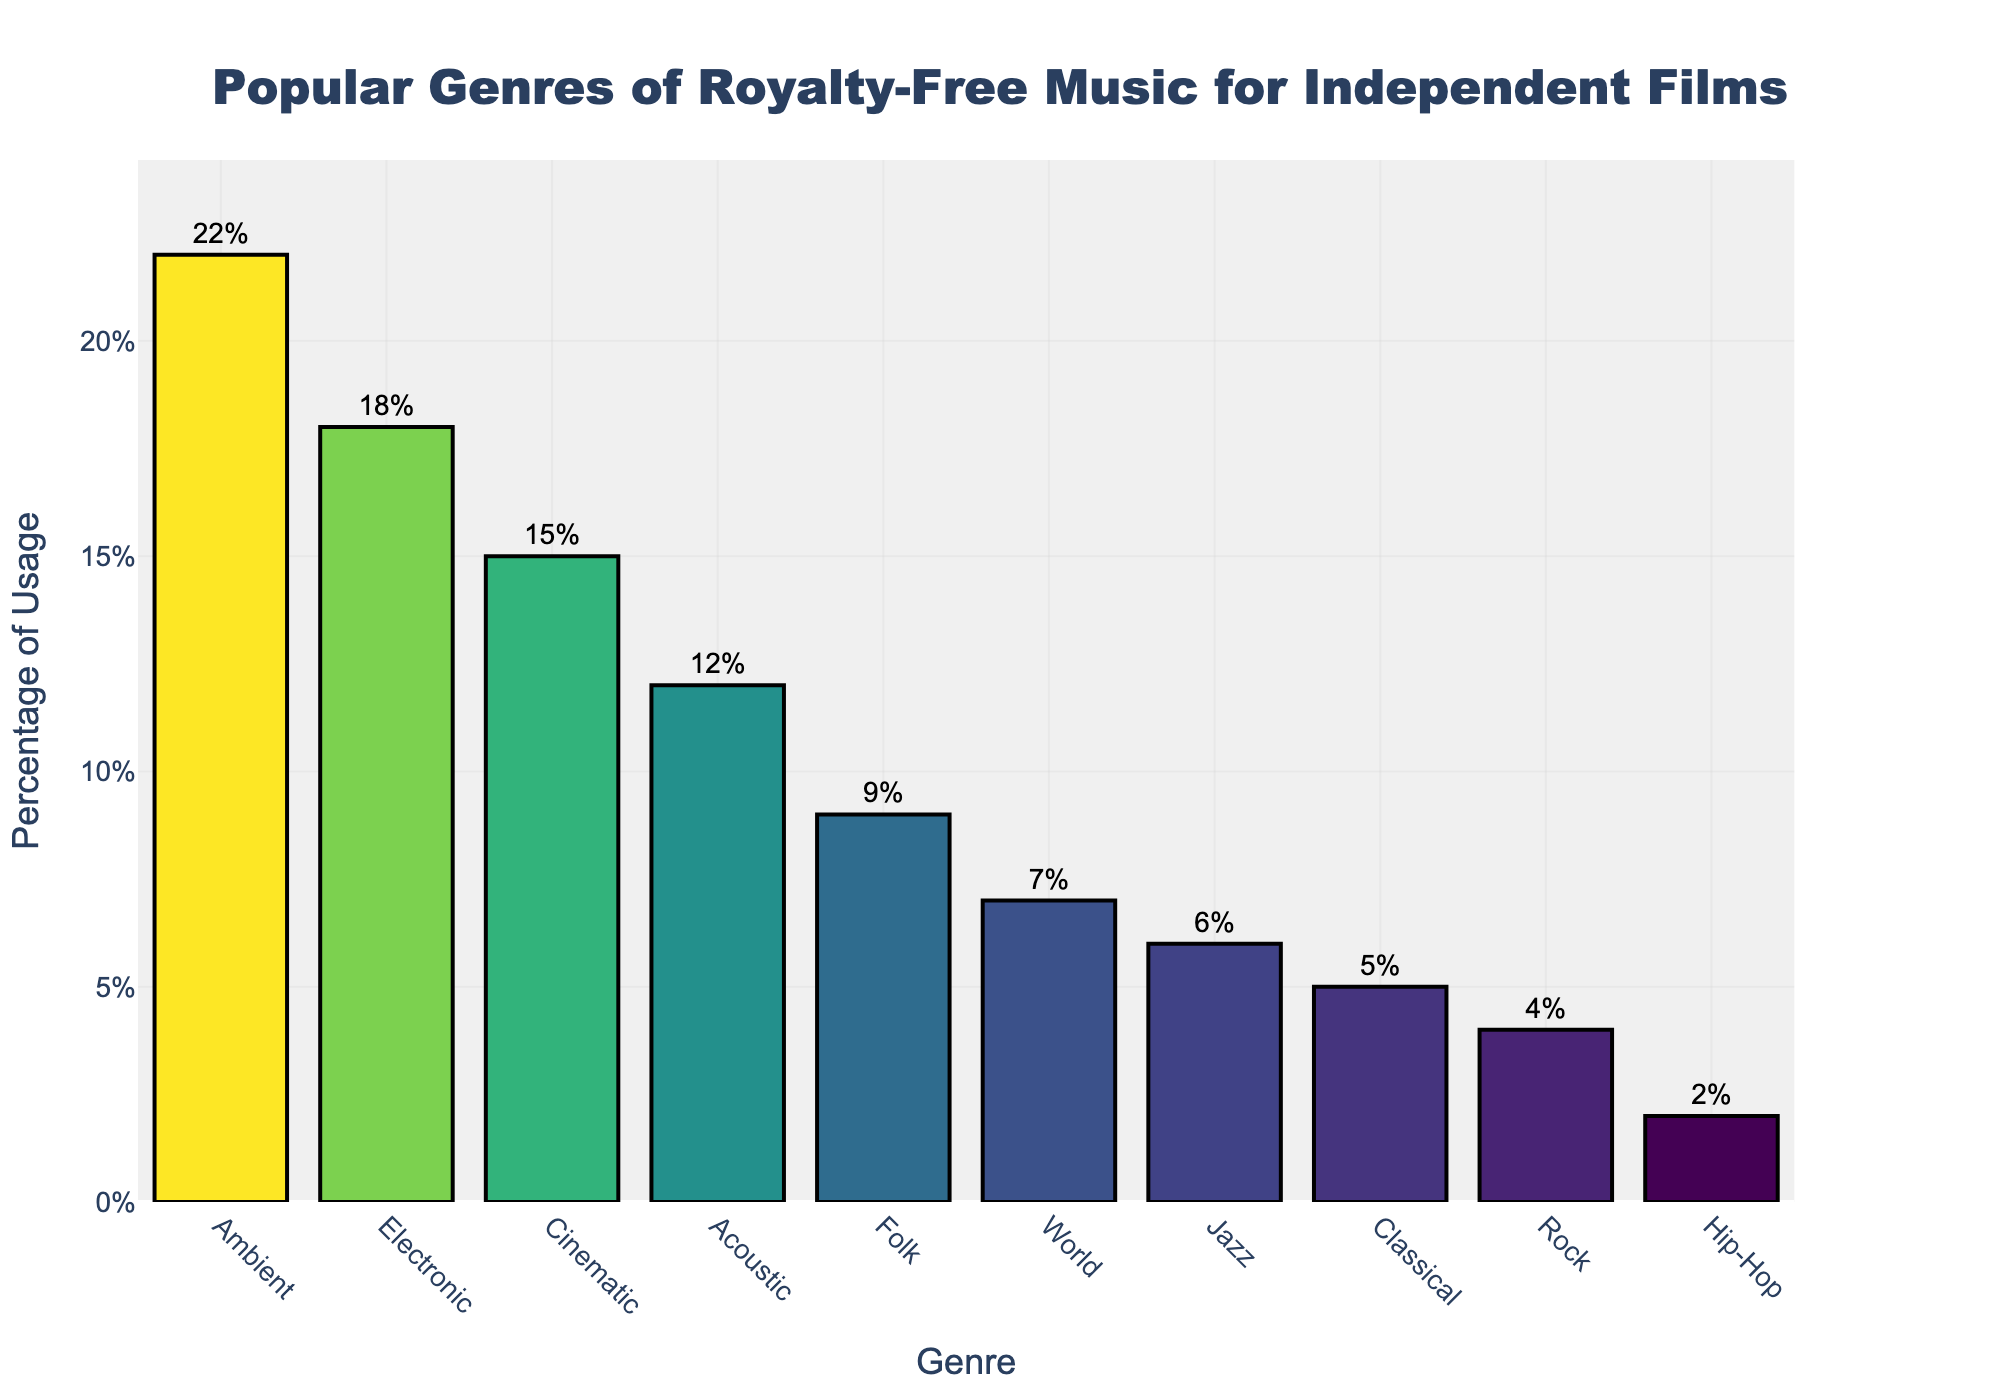Which genre is the most popular for royalty-free music in independent films? The genre with the highest bar and percentage shown in the figure is the most popular. The "Ambient" genre is shown to have the highest percentage of usage.
Answer: Ambient How much more popular is Ambient compared to Electronic music? To find the difference, subtract the percentage of Electronic music from Ambient. The percentage for Ambient is 22%, and for Electronic it is 18%, therefore 22% - 18% = 4%.
Answer: 4% What is the combined percentage of Cinematic, Acoustic, and Folk music usage? Add the percentages of Cinematic, Acoustic, and Folk music. Cinematic is 15%, Acoustic is 12%, and Folk is 9%. So, 15% + 12% + 9% = 36%.
Answer: 36% Which genre has the lowest usage in royalty-free music for independent films? Look for the bar with the lowest height. "Hip-Hop" is listed as having the lowest percentage usage of 2%.
Answer: Hip-Hop Are there any music genres that have a usage percentage less than 10%? If so, which ones? Identify the genres with a percentage less than 10%. According to the bar chart, Folk, World, Jazz, Classical, Rock, and Hip-Hop all have percentages less than 10%.
Answer: Folk, World, Jazz, Classical, Rock, Hip-Hop How does the usage percentage of Jazz compare to Classical music? Compare the heights of the bars for Jazz and Classical music. Jazz has a percentage usage of 6% and Classical has 5%. Jazz is higher than Classical by 1%.
Answer: Jazz usage is higher by 1% Which genres have equal or greater usage than Acoustic music? Identify the genres whose bars are equal to or taller than the bar for Acoustic music, which has 12%. The genres that meet this criteria are Ambient (22%), Electronic (18%), and Cinematic (15%).
Answer: Ambient, Electronic, Cinematic What is the average percentage usage of World, Jazz, Classical, and Rock music? To find the average, add the percentages of these genres and divide by the number of genres. World is 7%, Jazz is 6%, Classical is 5%, and Rock is 4%. Therefore, (7% + 6% + 5% + 4%) / 4 = 22% / 4 = 5.5%.
Answer: 5.5% How much higher is the usage percentage of Cinematic music compared to Folk music? Subtract the percentage of Folk music from that of Cinematic music. Cinematic is 15% and Folk is 9%. So, 15% - 9% = 6%.
Answer: 6% Do more genres fall into the usage percentage range of 5% to 10% or 1% to 5%? Count the number of genres within each range. In the 5% to 10% range: Folk (9%), World (7%), Jazz (6%), Classical (5%). That's 4 genres. In the 1% to 5% range: Classical (5%), Rock (4%), Hip-Hop (2%). That's 3 genres.
Answer: More genres fall in the 5% to 10% range 